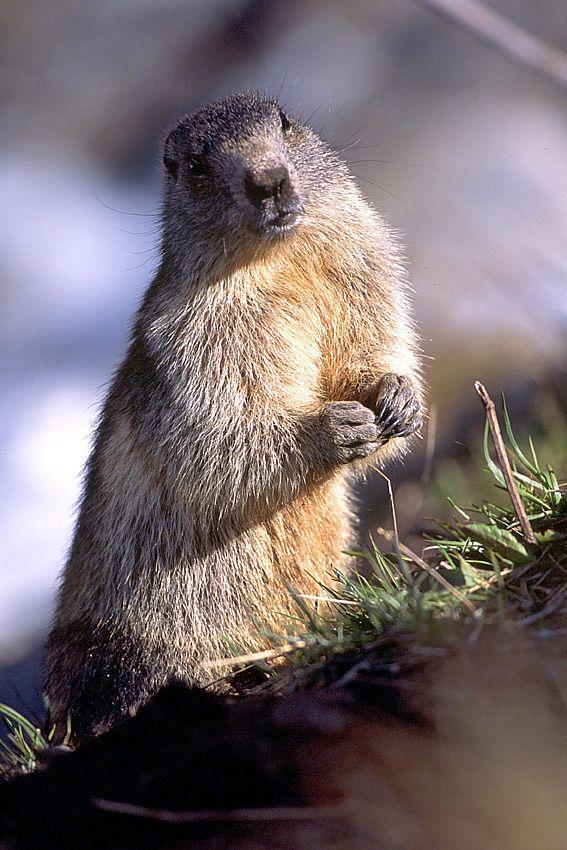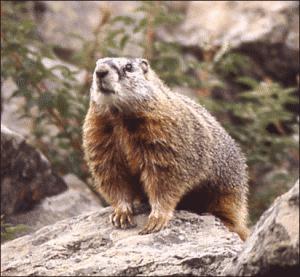The first image is the image on the left, the second image is the image on the right. Assess this claim about the two images: "At least one image contains two animals.". Correct or not? Answer yes or no. No. 